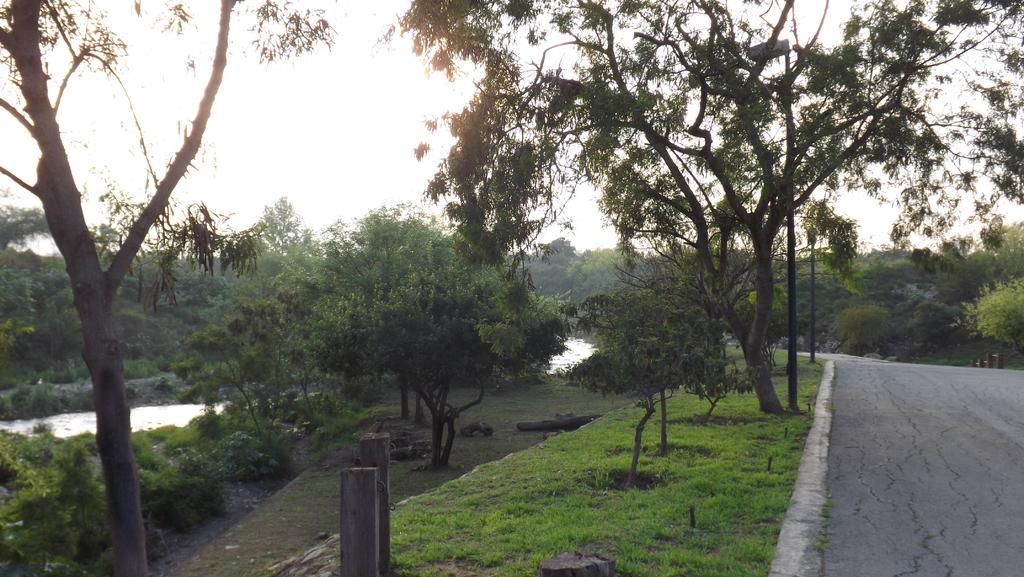Please provide a concise description of this image. In the background we can see the sky. In this picture we can see the trees, green grass, wooden poles and the water. On the right side of the picture we can see the road. 